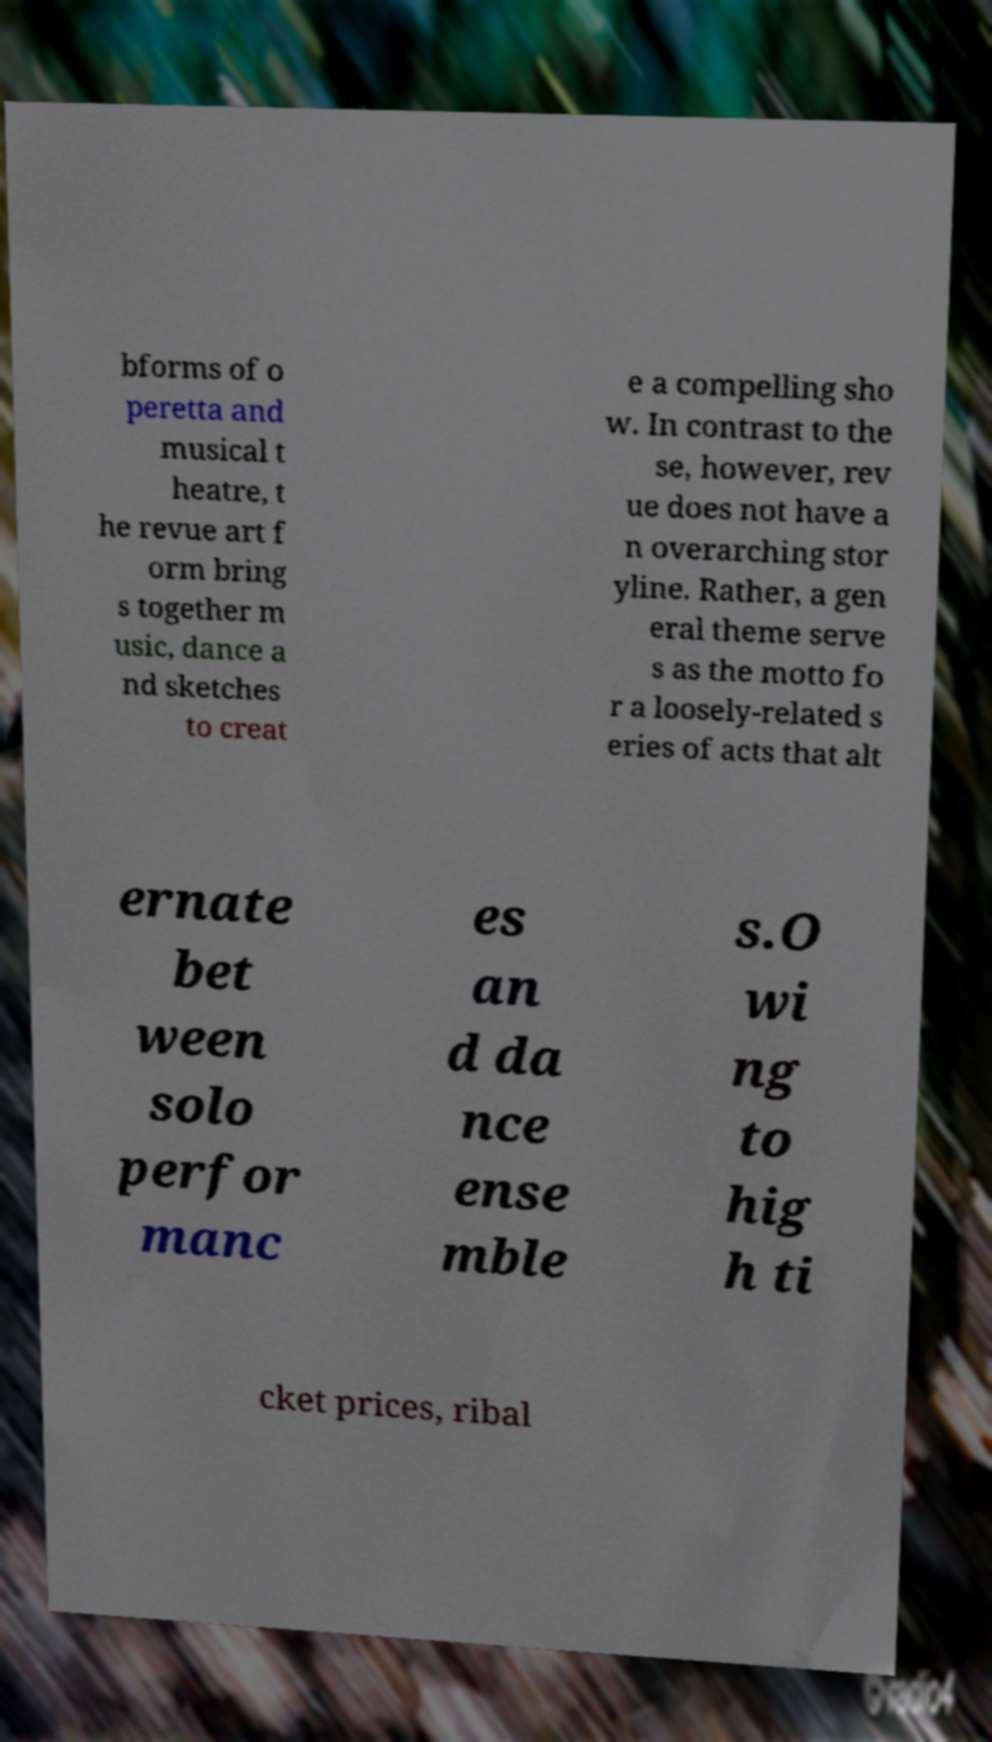Could you extract and type out the text from this image? bforms of o peretta and musical t heatre, t he revue art f orm bring s together m usic, dance a nd sketches to creat e a compelling sho w. In contrast to the se, however, rev ue does not have a n overarching stor yline. Rather, a gen eral theme serve s as the motto fo r a loosely-related s eries of acts that alt ernate bet ween solo perfor manc es an d da nce ense mble s.O wi ng to hig h ti cket prices, ribal 